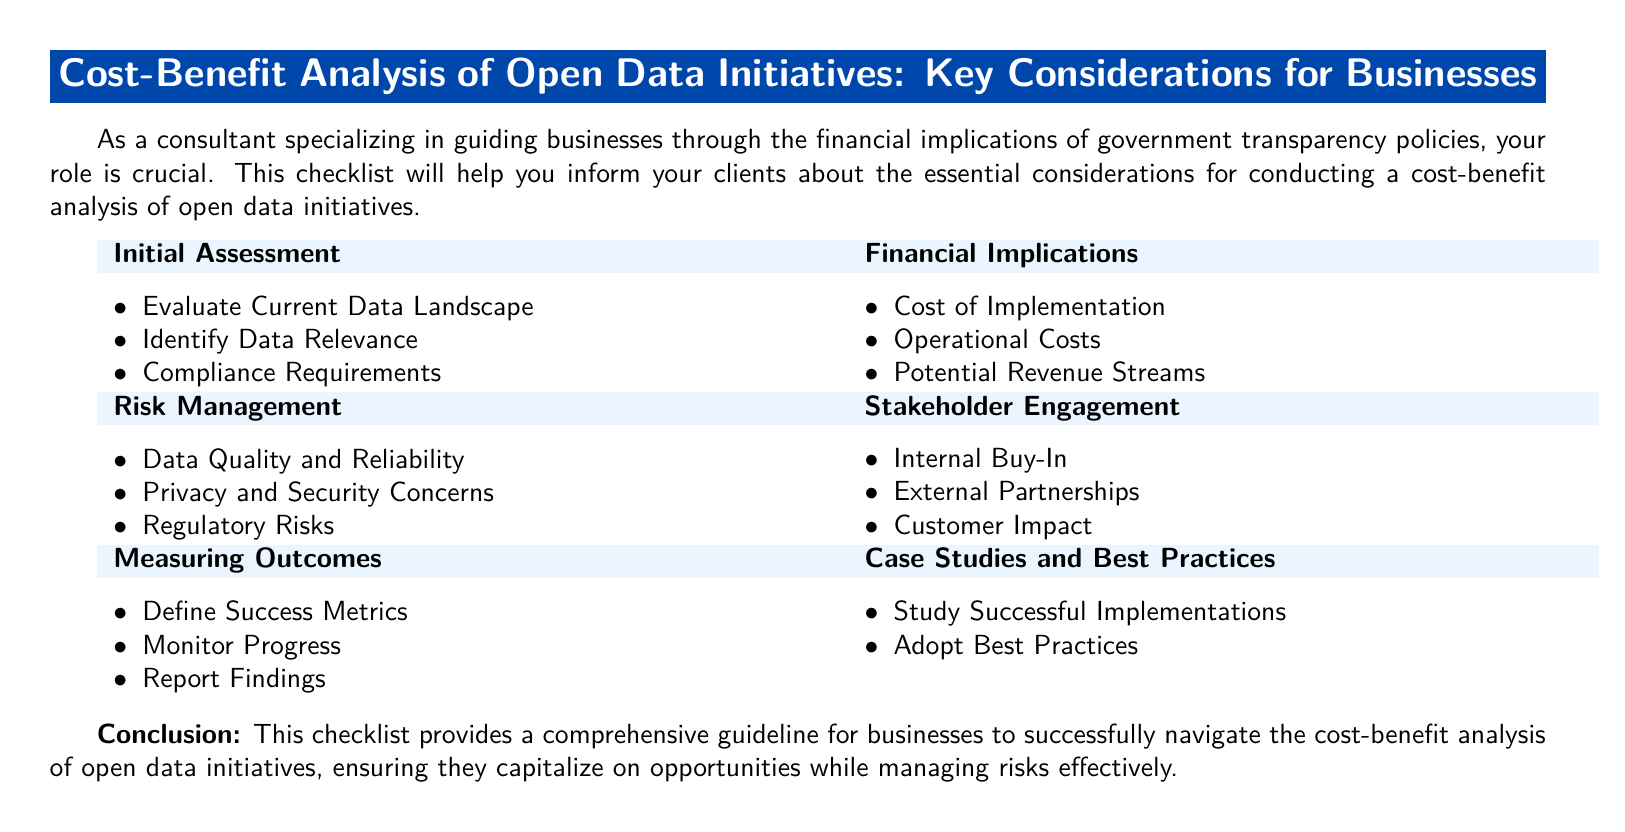What is the title of the document? The title of the document is provided in the heading box at the top, which states "Cost-Benefit Analysis of Open Data Initiatives: Key Considerations for Businesses."
Answer: Cost-Benefit Analysis of Open Data Initiatives: Key Considerations for Businesses How many sections are there in the checklist? The checklist contains six main sections, revealed in the tabular format of the document.
Answer: Six What is one item listed under "Initial Assessment"? The document lists evaluation points under "Initial Assessment," including "Evaluate Current Data Landscape."
Answer: Evaluate Current Data Landscape What financial implication is highlighted regarding potential revenue? The document includes "Potential Revenue Streams" as a financial implication related to open data initiatives.
Answer: Potential Revenue Streams What is a risk management concern mentioned? The checklist includes multiple items, one being "Data Quality and Reliability" as a risk management concern.
Answer: Data Quality and Reliability What is the purpose of defining success metrics? The document states that defining success metrics is part of "Measuring Outcomes," which indicates tracking effectiveness.
Answer: Monitor Progress How many aspects are covered under "Case Studies and Best Practices"? There are two aspects listed under "Case Studies and Best Practices."
Answer: Two What is one method suggested for reporting outcomes? Reporting outcomes is mentioned under "Measuring Outcomes," with "Report Findings" as a suggested method.
Answer: Report Findings 